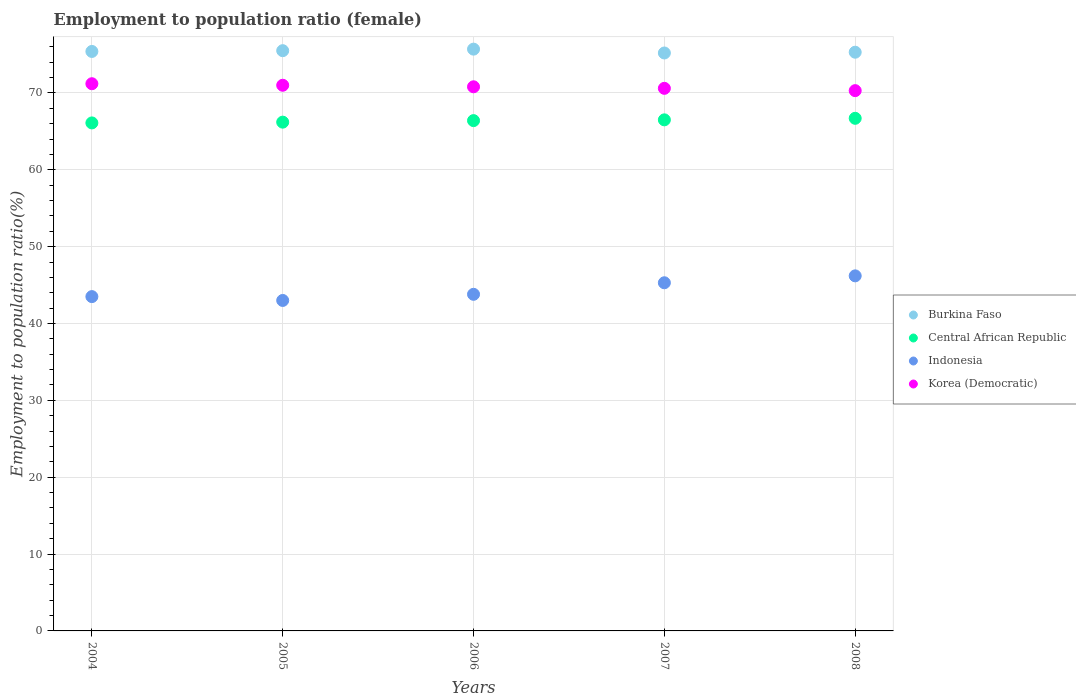How many different coloured dotlines are there?
Give a very brief answer. 4. What is the employment to population ratio in Indonesia in 2004?
Give a very brief answer. 43.5. Across all years, what is the maximum employment to population ratio in Korea (Democratic)?
Provide a succinct answer. 71.2. Across all years, what is the minimum employment to population ratio in Korea (Democratic)?
Your answer should be compact. 70.3. What is the total employment to population ratio in Burkina Faso in the graph?
Keep it short and to the point. 377.1. What is the difference between the employment to population ratio in Burkina Faso in 2004 and that in 2006?
Ensure brevity in your answer.  -0.3. What is the difference between the employment to population ratio in Korea (Democratic) in 2004 and the employment to population ratio in Indonesia in 2008?
Keep it short and to the point. 25. What is the average employment to population ratio in Indonesia per year?
Your answer should be compact. 44.36. In the year 2008, what is the difference between the employment to population ratio in Burkina Faso and employment to population ratio in Indonesia?
Ensure brevity in your answer.  29.1. What is the ratio of the employment to population ratio in Korea (Democratic) in 2004 to that in 2008?
Keep it short and to the point. 1.01. What is the difference between the highest and the second highest employment to population ratio in Indonesia?
Your answer should be very brief. 0.9. What is the difference between the highest and the lowest employment to population ratio in Indonesia?
Your answer should be very brief. 3.2. Is the sum of the employment to population ratio in Burkina Faso in 2004 and 2005 greater than the maximum employment to population ratio in Korea (Democratic) across all years?
Provide a succinct answer. Yes. Is it the case that in every year, the sum of the employment to population ratio in Central African Republic and employment to population ratio in Indonesia  is greater than the employment to population ratio in Burkina Faso?
Keep it short and to the point. Yes. Does the employment to population ratio in Burkina Faso monotonically increase over the years?
Provide a short and direct response. No. Is the employment to population ratio in Central African Republic strictly greater than the employment to population ratio in Burkina Faso over the years?
Provide a succinct answer. No. Is the employment to population ratio in Central African Republic strictly less than the employment to population ratio in Burkina Faso over the years?
Provide a short and direct response. Yes. How many years are there in the graph?
Make the answer very short. 5. What is the difference between two consecutive major ticks on the Y-axis?
Ensure brevity in your answer.  10. Does the graph contain any zero values?
Provide a short and direct response. No. Does the graph contain grids?
Keep it short and to the point. Yes. Where does the legend appear in the graph?
Provide a succinct answer. Center right. How many legend labels are there?
Your response must be concise. 4. What is the title of the graph?
Make the answer very short. Employment to population ratio (female). Does "Turks and Caicos Islands" appear as one of the legend labels in the graph?
Make the answer very short. No. What is the label or title of the X-axis?
Give a very brief answer. Years. What is the Employment to population ratio(%) of Burkina Faso in 2004?
Provide a succinct answer. 75.4. What is the Employment to population ratio(%) in Central African Republic in 2004?
Ensure brevity in your answer.  66.1. What is the Employment to population ratio(%) in Indonesia in 2004?
Your answer should be compact. 43.5. What is the Employment to population ratio(%) in Korea (Democratic) in 2004?
Provide a succinct answer. 71.2. What is the Employment to population ratio(%) in Burkina Faso in 2005?
Offer a very short reply. 75.5. What is the Employment to population ratio(%) in Central African Republic in 2005?
Your answer should be very brief. 66.2. What is the Employment to population ratio(%) of Korea (Democratic) in 2005?
Offer a terse response. 71. What is the Employment to population ratio(%) in Burkina Faso in 2006?
Ensure brevity in your answer.  75.7. What is the Employment to population ratio(%) in Central African Republic in 2006?
Provide a succinct answer. 66.4. What is the Employment to population ratio(%) of Indonesia in 2006?
Make the answer very short. 43.8. What is the Employment to population ratio(%) of Korea (Democratic) in 2006?
Make the answer very short. 70.8. What is the Employment to population ratio(%) in Burkina Faso in 2007?
Your answer should be compact. 75.2. What is the Employment to population ratio(%) of Central African Republic in 2007?
Offer a terse response. 66.5. What is the Employment to population ratio(%) of Indonesia in 2007?
Give a very brief answer. 45.3. What is the Employment to population ratio(%) in Korea (Democratic) in 2007?
Make the answer very short. 70.6. What is the Employment to population ratio(%) in Burkina Faso in 2008?
Your answer should be compact. 75.3. What is the Employment to population ratio(%) in Central African Republic in 2008?
Offer a very short reply. 66.7. What is the Employment to population ratio(%) in Indonesia in 2008?
Make the answer very short. 46.2. What is the Employment to population ratio(%) of Korea (Democratic) in 2008?
Your answer should be compact. 70.3. Across all years, what is the maximum Employment to population ratio(%) in Burkina Faso?
Ensure brevity in your answer.  75.7. Across all years, what is the maximum Employment to population ratio(%) in Central African Republic?
Your answer should be compact. 66.7. Across all years, what is the maximum Employment to population ratio(%) of Indonesia?
Ensure brevity in your answer.  46.2. Across all years, what is the maximum Employment to population ratio(%) of Korea (Democratic)?
Offer a very short reply. 71.2. Across all years, what is the minimum Employment to population ratio(%) in Burkina Faso?
Provide a short and direct response. 75.2. Across all years, what is the minimum Employment to population ratio(%) of Central African Republic?
Give a very brief answer. 66.1. Across all years, what is the minimum Employment to population ratio(%) in Indonesia?
Offer a very short reply. 43. Across all years, what is the minimum Employment to population ratio(%) of Korea (Democratic)?
Provide a succinct answer. 70.3. What is the total Employment to population ratio(%) of Burkina Faso in the graph?
Provide a succinct answer. 377.1. What is the total Employment to population ratio(%) of Central African Republic in the graph?
Offer a very short reply. 331.9. What is the total Employment to population ratio(%) in Indonesia in the graph?
Your answer should be compact. 221.8. What is the total Employment to population ratio(%) in Korea (Democratic) in the graph?
Your response must be concise. 353.9. What is the difference between the Employment to population ratio(%) in Burkina Faso in 2004 and that in 2005?
Offer a terse response. -0.1. What is the difference between the Employment to population ratio(%) in Central African Republic in 2004 and that in 2005?
Your answer should be very brief. -0.1. What is the difference between the Employment to population ratio(%) in Burkina Faso in 2004 and that in 2006?
Your answer should be compact. -0.3. What is the difference between the Employment to population ratio(%) of Korea (Democratic) in 2004 and that in 2006?
Offer a terse response. 0.4. What is the difference between the Employment to population ratio(%) in Central African Republic in 2004 and that in 2007?
Provide a short and direct response. -0.4. What is the difference between the Employment to population ratio(%) in Korea (Democratic) in 2004 and that in 2008?
Your answer should be very brief. 0.9. What is the difference between the Employment to population ratio(%) of Central African Republic in 2005 and that in 2006?
Provide a succinct answer. -0.2. What is the difference between the Employment to population ratio(%) in Korea (Democratic) in 2005 and that in 2006?
Keep it short and to the point. 0.2. What is the difference between the Employment to population ratio(%) of Central African Republic in 2005 and that in 2008?
Provide a short and direct response. -0.5. What is the difference between the Employment to population ratio(%) in Indonesia in 2005 and that in 2008?
Your answer should be compact. -3.2. What is the difference between the Employment to population ratio(%) of Burkina Faso in 2006 and that in 2007?
Provide a succinct answer. 0.5. What is the difference between the Employment to population ratio(%) of Central African Republic in 2006 and that in 2007?
Provide a short and direct response. -0.1. What is the difference between the Employment to population ratio(%) of Indonesia in 2006 and that in 2007?
Provide a succinct answer. -1.5. What is the difference between the Employment to population ratio(%) in Burkina Faso in 2006 and that in 2008?
Your answer should be compact. 0.4. What is the difference between the Employment to population ratio(%) in Central African Republic in 2006 and that in 2008?
Ensure brevity in your answer.  -0.3. What is the difference between the Employment to population ratio(%) in Korea (Democratic) in 2006 and that in 2008?
Make the answer very short. 0.5. What is the difference between the Employment to population ratio(%) of Central African Republic in 2007 and that in 2008?
Give a very brief answer. -0.2. What is the difference between the Employment to population ratio(%) in Indonesia in 2007 and that in 2008?
Provide a succinct answer. -0.9. What is the difference between the Employment to population ratio(%) of Korea (Democratic) in 2007 and that in 2008?
Your answer should be compact. 0.3. What is the difference between the Employment to population ratio(%) in Burkina Faso in 2004 and the Employment to population ratio(%) in Central African Republic in 2005?
Your answer should be compact. 9.2. What is the difference between the Employment to population ratio(%) of Burkina Faso in 2004 and the Employment to population ratio(%) of Indonesia in 2005?
Your answer should be compact. 32.4. What is the difference between the Employment to population ratio(%) of Central African Republic in 2004 and the Employment to population ratio(%) of Indonesia in 2005?
Provide a short and direct response. 23.1. What is the difference between the Employment to population ratio(%) in Indonesia in 2004 and the Employment to population ratio(%) in Korea (Democratic) in 2005?
Make the answer very short. -27.5. What is the difference between the Employment to population ratio(%) in Burkina Faso in 2004 and the Employment to population ratio(%) in Indonesia in 2006?
Give a very brief answer. 31.6. What is the difference between the Employment to population ratio(%) in Central African Republic in 2004 and the Employment to population ratio(%) in Indonesia in 2006?
Your answer should be very brief. 22.3. What is the difference between the Employment to population ratio(%) of Central African Republic in 2004 and the Employment to population ratio(%) of Korea (Democratic) in 2006?
Give a very brief answer. -4.7. What is the difference between the Employment to population ratio(%) in Indonesia in 2004 and the Employment to population ratio(%) in Korea (Democratic) in 2006?
Give a very brief answer. -27.3. What is the difference between the Employment to population ratio(%) in Burkina Faso in 2004 and the Employment to population ratio(%) in Indonesia in 2007?
Provide a short and direct response. 30.1. What is the difference between the Employment to population ratio(%) in Central African Republic in 2004 and the Employment to population ratio(%) in Indonesia in 2007?
Offer a very short reply. 20.8. What is the difference between the Employment to population ratio(%) in Indonesia in 2004 and the Employment to population ratio(%) in Korea (Democratic) in 2007?
Your response must be concise. -27.1. What is the difference between the Employment to population ratio(%) of Burkina Faso in 2004 and the Employment to population ratio(%) of Indonesia in 2008?
Provide a succinct answer. 29.2. What is the difference between the Employment to population ratio(%) of Burkina Faso in 2004 and the Employment to population ratio(%) of Korea (Democratic) in 2008?
Your response must be concise. 5.1. What is the difference between the Employment to population ratio(%) of Central African Republic in 2004 and the Employment to population ratio(%) of Indonesia in 2008?
Your answer should be very brief. 19.9. What is the difference between the Employment to population ratio(%) in Central African Republic in 2004 and the Employment to population ratio(%) in Korea (Democratic) in 2008?
Keep it short and to the point. -4.2. What is the difference between the Employment to population ratio(%) in Indonesia in 2004 and the Employment to population ratio(%) in Korea (Democratic) in 2008?
Give a very brief answer. -26.8. What is the difference between the Employment to population ratio(%) of Burkina Faso in 2005 and the Employment to population ratio(%) of Indonesia in 2006?
Your answer should be compact. 31.7. What is the difference between the Employment to population ratio(%) of Burkina Faso in 2005 and the Employment to population ratio(%) of Korea (Democratic) in 2006?
Your response must be concise. 4.7. What is the difference between the Employment to population ratio(%) of Central African Republic in 2005 and the Employment to population ratio(%) of Indonesia in 2006?
Provide a short and direct response. 22.4. What is the difference between the Employment to population ratio(%) of Indonesia in 2005 and the Employment to population ratio(%) of Korea (Democratic) in 2006?
Keep it short and to the point. -27.8. What is the difference between the Employment to population ratio(%) in Burkina Faso in 2005 and the Employment to population ratio(%) in Indonesia in 2007?
Ensure brevity in your answer.  30.2. What is the difference between the Employment to population ratio(%) in Burkina Faso in 2005 and the Employment to population ratio(%) in Korea (Democratic) in 2007?
Give a very brief answer. 4.9. What is the difference between the Employment to population ratio(%) in Central African Republic in 2005 and the Employment to population ratio(%) in Indonesia in 2007?
Your answer should be compact. 20.9. What is the difference between the Employment to population ratio(%) of Central African Republic in 2005 and the Employment to population ratio(%) of Korea (Democratic) in 2007?
Give a very brief answer. -4.4. What is the difference between the Employment to population ratio(%) of Indonesia in 2005 and the Employment to population ratio(%) of Korea (Democratic) in 2007?
Ensure brevity in your answer.  -27.6. What is the difference between the Employment to population ratio(%) of Burkina Faso in 2005 and the Employment to population ratio(%) of Central African Republic in 2008?
Your response must be concise. 8.8. What is the difference between the Employment to population ratio(%) in Burkina Faso in 2005 and the Employment to population ratio(%) in Indonesia in 2008?
Make the answer very short. 29.3. What is the difference between the Employment to population ratio(%) of Burkina Faso in 2005 and the Employment to population ratio(%) of Korea (Democratic) in 2008?
Offer a very short reply. 5.2. What is the difference between the Employment to population ratio(%) in Central African Republic in 2005 and the Employment to population ratio(%) in Korea (Democratic) in 2008?
Offer a terse response. -4.1. What is the difference between the Employment to population ratio(%) of Indonesia in 2005 and the Employment to population ratio(%) of Korea (Democratic) in 2008?
Your response must be concise. -27.3. What is the difference between the Employment to population ratio(%) of Burkina Faso in 2006 and the Employment to population ratio(%) of Indonesia in 2007?
Offer a very short reply. 30.4. What is the difference between the Employment to population ratio(%) of Central African Republic in 2006 and the Employment to population ratio(%) of Indonesia in 2007?
Provide a short and direct response. 21.1. What is the difference between the Employment to population ratio(%) of Central African Republic in 2006 and the Employment to population ratio(%) of Korea (Democratic) in 2007?
Offer a very short reply. -4.2. What is the difference between the Employment to population ratio(%) in Indonesia in 2006 and the Employment to population ratio(%) in Korea (Democratic) in 2007?
Your answer should be very brief. -26.8. What is the difference between the Employment to population ratio(%) of Burkina Faso in 2006 and the Employment to population ratio(%) of Indonesia in 2008?
Your response must be concise. 29.5. What is the difference between the Employment to population ratio(%) in Central African Republic in 2006 and the Employment to population ratio(%) in Indonesia in 2008?
Give a very brief answer. 20.2. What is the difference between the Employment to population ratio(%) in Indonesia in 2006 and the Employment to population ratio(%) in Korea (Democratic) in 2008?
Provide a short and direct response. -26.5. What is the difference between the Employment to population ratio(%) of Burkina Faso in 2007 and the Employment to population ratio(%) of Central African Republic in 2008?
Make the answer very short. 8.5. What is the difference between the Employment to population ratio(%) of Central African Republic in 2007 and the Employment to population ratio(%) of Indonesia in 2008?
Give a very brief answer. 20.3. What is the difference between the Employment to population ratio(%) in Indonesia in 2007 and the Employment to population ratio(%) in Korea (Democratic) in 2008?
Offer a very short reply. -25. What is the average Employment to population ratio(%) of Burkina Faso per year?
Offer a very short reply. 75.42. What is the average Employment to population ratio(%) in Central African Republic per year?
Provide a short and direct response. 66.38. What is the average Employment to population ratio(%) in Indonesia per year?
Provide a succinct answer. 44.36. What is the average Employment to population ratio(%) of Korea (Democratic) per year?
Your answer should be compact. 70.78. In the year 2004, what is the difference between the Employment to population ratio(%) in Burkina Faso and Employment to population ratio(%) in Central African Republic?
Ensure brevity in your answer.  9.3. In the year 2004, what is the difference between the Employment to population ratio(%) of Burkina Faso and Employment to population ratio(%) of Indonesia?
Provide a succinct answer. 31.9. In the year 2004, what is the difference between the Employment to population ratio(%) in Burkina Faso and Employment to population ratio(%) in Korea (Democratic)?
Give a very brief answer. 4.2. In the year 2004, what is the difference between the Employment to population ratio(%) of Central African Republic and Employment to population ratio(%) of Indonesia?
Keep it short and to the point. 22.6. In the year 2004, what is the difference between the Employment to population ratio(%) in Indonesia and Employment to population ratio(%) in Korea (Democratic)?
Your answer should be compact. -27.7. In the year 2005, what is the difference between the Employment to population ratio(%) of Burkina Faso and Employment to population ratio(%) of Indonesia?
Make the answer very short. 32.5. In the year 2005, what is the difference between the Employment to population ratio(%) in Burkina Faso and Employment to population ratio(%) in Korea (Democratic)?
Make the answer very short. 4.5. In the year 2005, what is the difference between the Employment to population ratio(%) in Central African Republic and Employment to population ratio(%) in Indonesia?
Offer a terse response. 23.2. In the year 2005, what is the difference between the Employment to population ratio(%) of Central African Republic and Employment to population ratio(%) of Korea (Democratic)?
Offer a terse response. -4.8. In the year 2006, what is the difference between the Employment to population ratio(%) of Burkina Faso and Employment to population ratio(%) of Central African Republic?
Provide a short and direct response. 9.3. In the year 2006, what is the difference between the Employment to population ratio(%) in Burkina Faso and Employment to population ratio(%) in Indonesia?
Your answer should be compact. 31.9. In the year 2006, what is the difference between the Employment to population ratio(%) of Central African Republic and Employment to population ratio(%) of Indonesia?
Your response must be concise. 22.6. In the year 2006, what is the difference between the Employment to population ratio(%) in Central African Republic and Employment to population ratio(%) in Korea (Democratic)?
Offer a very short reply. -4.4. In the year 2006, what is the difference between the Employment to population ratio(%) of Indonesia and Employment to population ratio(%) of Korea (Democratic)?
Your response must be concise. -27. In the year 2007, what is the difference between the Employment to population ratio(%) of Burkina Faso and Employment to population ratio(%) of Central African Republic?
Your answer should be compact. 8.7. In the year 2007, what is the difference between the Employment to population ratio(%) in Burkina Faso and Employment to population ratio(%) in Indonesia?
Provide a succinct answer. 29.9. In the year 2007, what is the difference between the Employment to population ratio(%) of Central African Republic and Employment to population ratio(%) of Indonesia?
Make the answer very short. 21.2. In the year 2007, what is the difference between the Employment to population ratio(%) of Indonesia and Employment to population ratio(%) of Korea (Democratic)?
Make the answer very short. -25.3. In the year 2008, what is the difference between the Employment to population ratio(%) of Burkina Faso and Employment to population ratio(%) of Indonesia?
Your answer should be compact. 29.1. In the year 2008, what is the difference between the Employment to population ratio(%) of Burkina Faso and Employment to population ratio(%) of Korea (Democratic)?
Provide a short and direct response. 5. In the year 2008, what is the difference between the Employment to population ratio(%) in Central African Republic and Employment to population ratio(%) in Korea (Democratic)?
Your response must be concise. -3.6. In the year 2008, what is the difference between the Employment to population ratio(%) in Indonesia and Employment to population ratio(%) in Korea (Democratic)?
Provide a short and direct response. -24.1. What is the ratio of the Employment to population ratio(%) of Central African Republic in 2004 to that in 2005?
Offer a terse response. 1. What is the ratio of the Employment to population ratio(%) of Indonesia in 2004 to that in 2005?
Provide a short and direct response. 1.01. What is the ratio of the Employment to population ratio(%) in Burkina Faso in 2004 to that in 2006?
Keep it short and to the point. 1. What is the ratio of the Employment to population ratio(%) of Indonesia in 2004 to that in 2006?
Ensure brevity in your answer.  0.99. What is the ratio of the Employment to population ratio(%) in Korea (Democratic) in 2004 to that in 2006?
Ensure brevity in your answer.  1.01. What is the ratio of the Employment to population ratio(%) of Central African Republic in 2004 to that in 2007?
Provide a short and direct response. 0.99. What is the ratio of the Employment to population ratio(%) of Indonesia in 2004 to that in 2007?
Offer a very short reply. 0.96. What is the ratio of the Employment to population ratio(%) in Korea (Democratic) in 2004 to that in 2007?
Provide a short and direct response. 1.01. What is the ratio of the Employment to population ratio(%) of Burkina Faso in 2004 to that in 2008?
Keep it short and to the point. 1. What is the ratio of the Employment to population ratio(%) in Indonesia in 2004 to that in 2008?
Give a very brief answer. 0.94. What is the ratio of the Employment to population ratio(%) in Korea (Democratic) in 2004 to that in 2008?
Provide a short and direct response. 1.01. What is the ratio of the Employment to population ratio(%) in Burkina Faso in 2005 to that in 2006?
Your response must be concise. 1. What is the ratio of the Employment to population ratio(%) of Indonesia in 2005 to that in 2006?
Ensure brevity in your answer.  0.98. What is the ratio of the Employment to population ratio(%) of Korea (Democratic) in 2005 to that in 2006?
Make the answer very short. 1. What is the ratio of the Employment to population ratio(%) in Indonesia in 2005 to that in 2007?
Give a very brief answer. 0.95. What is the ratio of the Employment to population ratio(%) of Korea (Democratic) in 2005 to that in 2007?
Provide a short and direct response. 1.01. What is the ratio of the Employment to population ratio(%) in Indonesia in 2005 to that in 2008?
Provide a short and direct response. 0.93. What is the ratio of the Employment to population ratio(%) in Burkina Faso in 2006 to that in 2007?
Offer a very short reply. 1.01. What is the ratio of the Employment to population ratio(%) of Central African Republic in 2006 to that in 2007?
Provide a succinct answer. 1. What is the ratio of the Employment to population ratio(%) in Indonesia in 2006 to that in 2007?
Your response must be concise. 0.97. What is the ratio of the Employment to population ratio(%) in Burkina Faso in 2006 to that in 2008?
Your answer should be very brief. 1.01. What is the ratio of the Employment to population ratio(%) in Central African Republic in 2006 to that in 2008?
Offer a terse response. 1. What is the ratio of the Employment to population ratio(%) in Indonesia in 2006 to that in 2008?
Make the answer very short. 0.95. What is the ratio of the Employment to population ratio(%) in Korea (Democratic) in 2006 to that in 2008?
Keep it short and to the point. 1.01. What is the ratio of the Employment to population ratio(%) of Burkina Faso in 2007 to that in 2008?
Make the answer very short. 1. What is the ratio of the Employment to population ratio(%) in Indonesia in 2007 to that in 2008?
Your response must be concise. 0.98. What is the ratio of the Employment to population ratio(%) of Korea (Democratic) in 2007 to that in 2008?
Your answer should be very brief. 1. What is the difference between the highest and the second highest Employment to population ratio(%) in Burkina Faso?
Your response must be concise. 0.2. What is the difference between the highest and the second highest Employment to population ratio(%) in Korea (Democratic)?
Your response must be concise. 0.2. What is the difference between the highest and the lowest Employment to population ratio(%) in Central African Republic?
Your response must be concise. 0.6. What is the difference between the highest and the lowest Employment to population ratio(%) of Indonesia?
Your answer should be compact. 3.2. 